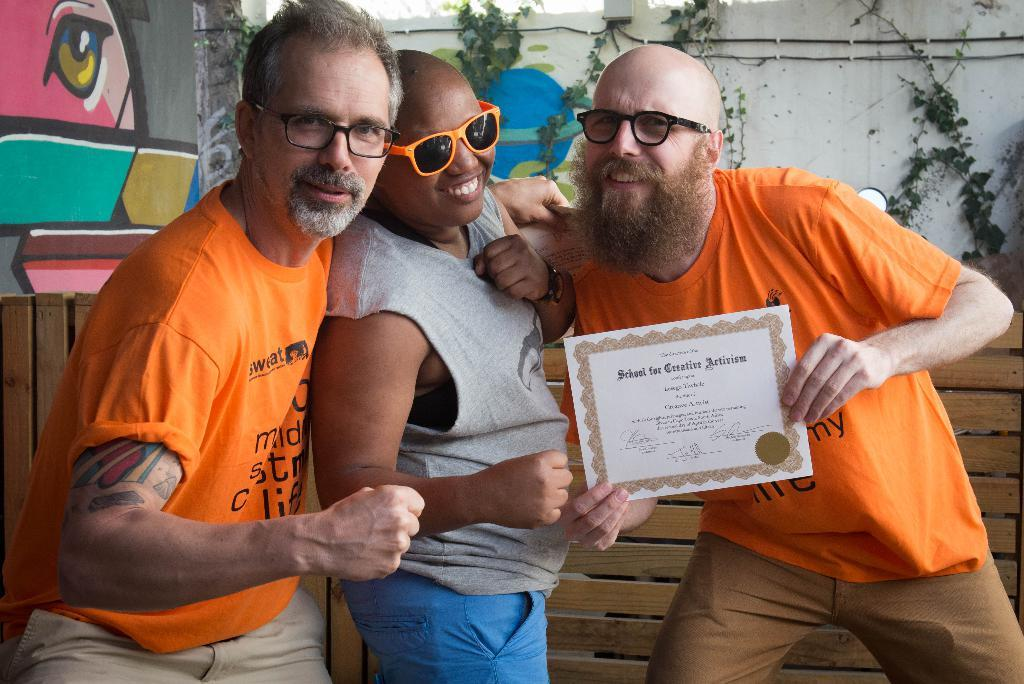What is the person in the image holding? The person is holding a certificate in the image. What are the other people in the image doing? There are two people standing and smiling in the image. What can be seen in the background of the image? There are plants and a wall in the background of the image. What type of scissors are being used to cut the approval in the image? There is no approval or scissors present in the image. 